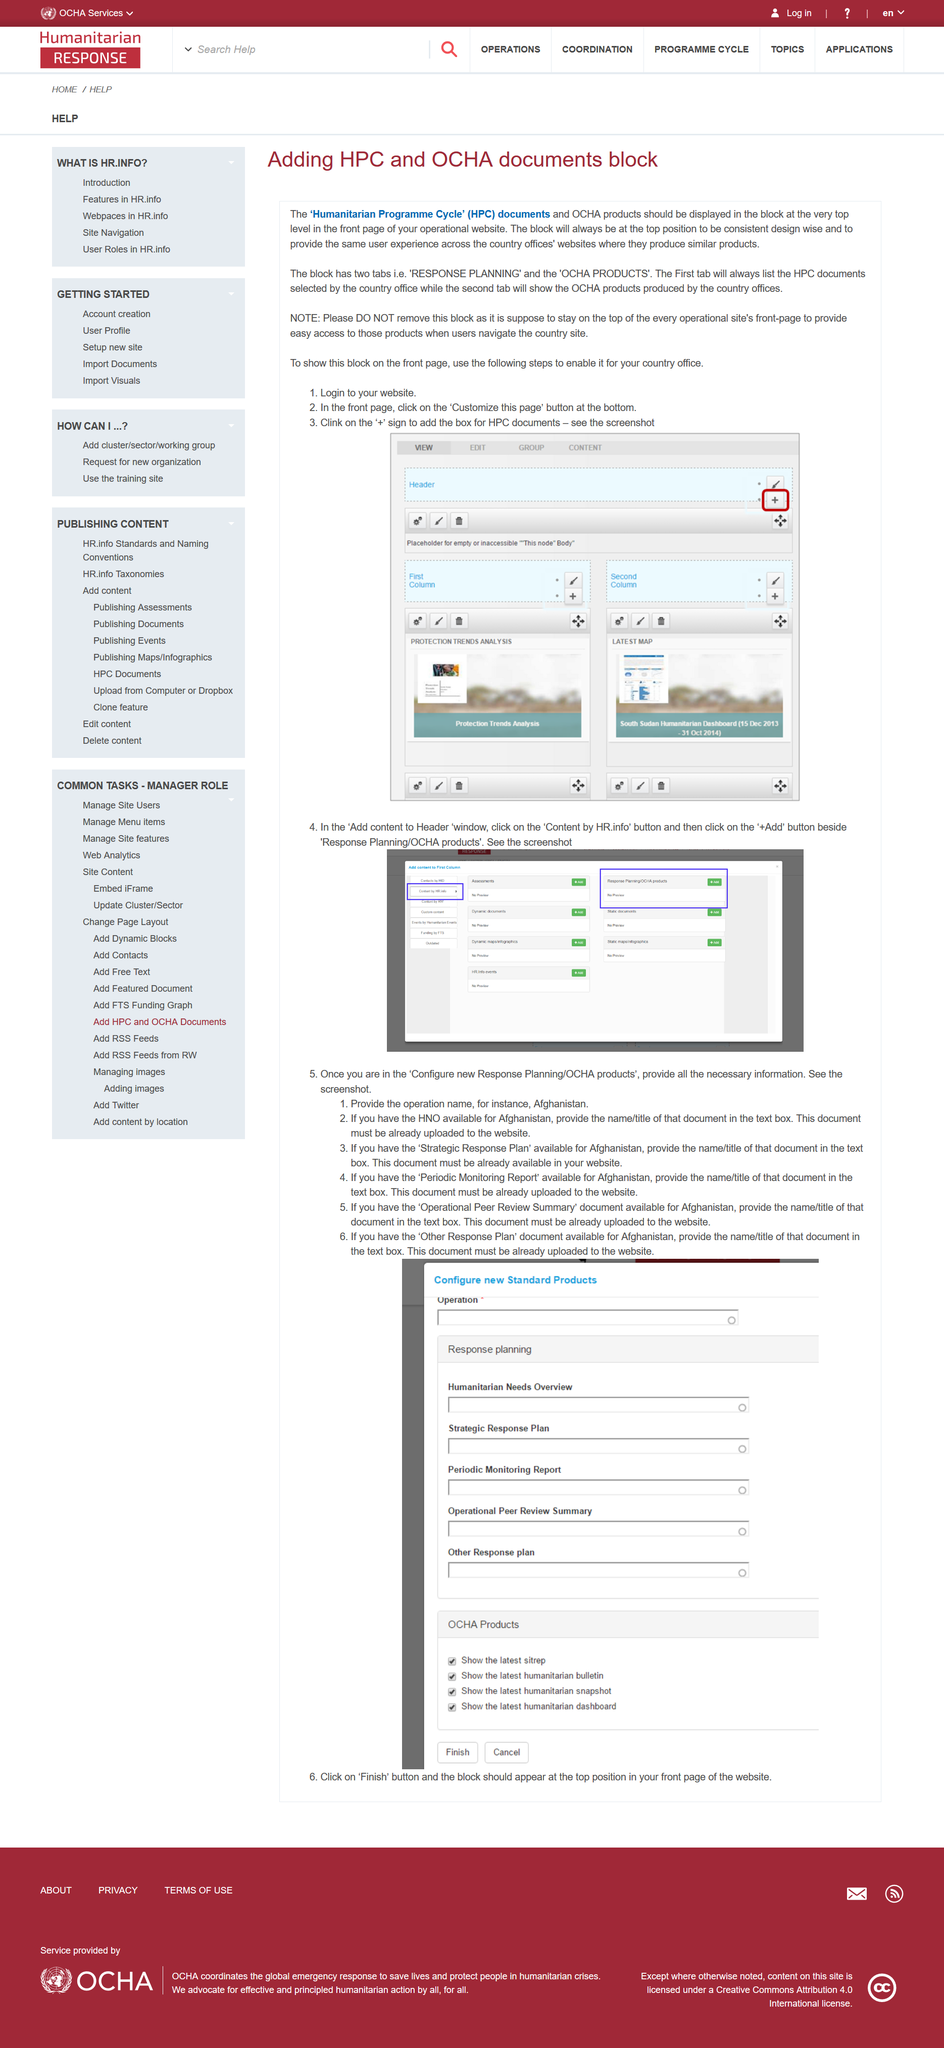Point out several critical features in this image. Step one is logging into the website. The overall process involves three steps. The Humanitarian Programme Cycle (HPC) is a framework used to address complex humanitarian emergencies, such as natural disasters and conflicts, in a systematic and coordinated manner. The HPC consists of five phases: (1) analysis and preparation, (2) response, (3) early recovery, (4) development, and (5) transition. Each phase has specific objectives and activities that aim to meet the needs of affected populations and support their recovery and development. The HPC is a critical tool for humanitarian actors to ensure a comprehensive and effective response to humanitarian emergencies. The document "Strategic Response Plan" for Afghanistan must already be uploaded to the website if the user provides its name/title in the text box. When accessing the "Configure new Response Planning/OCHA products" page, step number 1 requires providing the operation name. 